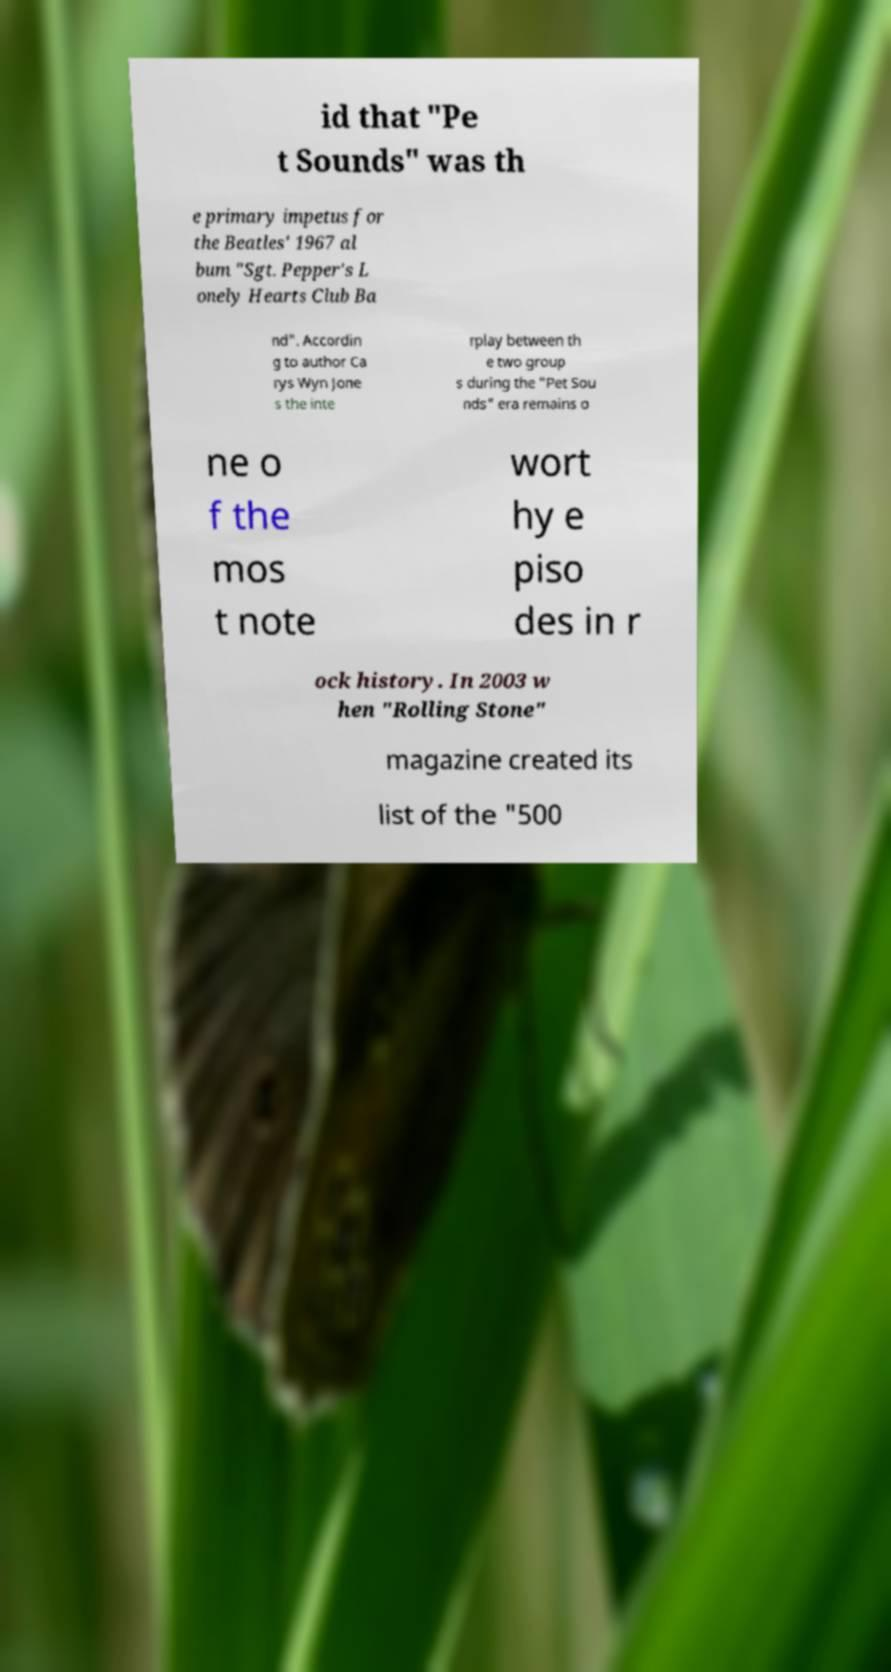Please identify and transcribe the text found in this image. id that "Pe t Sounds" was th e primary impetus for the Beatles' 1967 al bum "Sgt. Pepper's L onely Hearts Club Ba nd". Accordin g to author Ca rys Wyn Jone s the inte rplay between th e two group s during the "Pet Sou nds" era remains o ne o f the mos t note wort hy e piso des in r ock history. In 2003 w hen "Rolling Stone" magazine created its list of the "500 